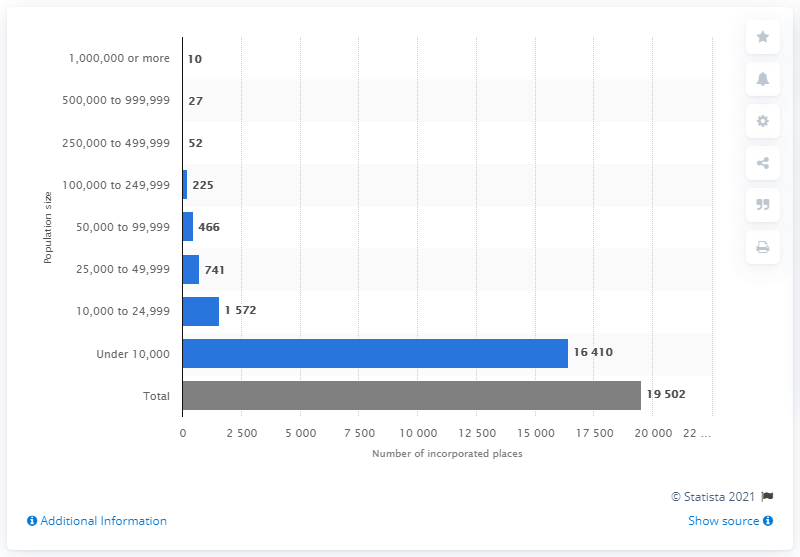List a handful of essential elements in this visual. It is unknown how many cities had a population under 10,000. The population size that had the least amount of cities, towns, and villages in 2019 was 1,000,000 or more. There were 17,982 towns, cities, and villages in the United States in 2019, with a population of less than 25,000. 